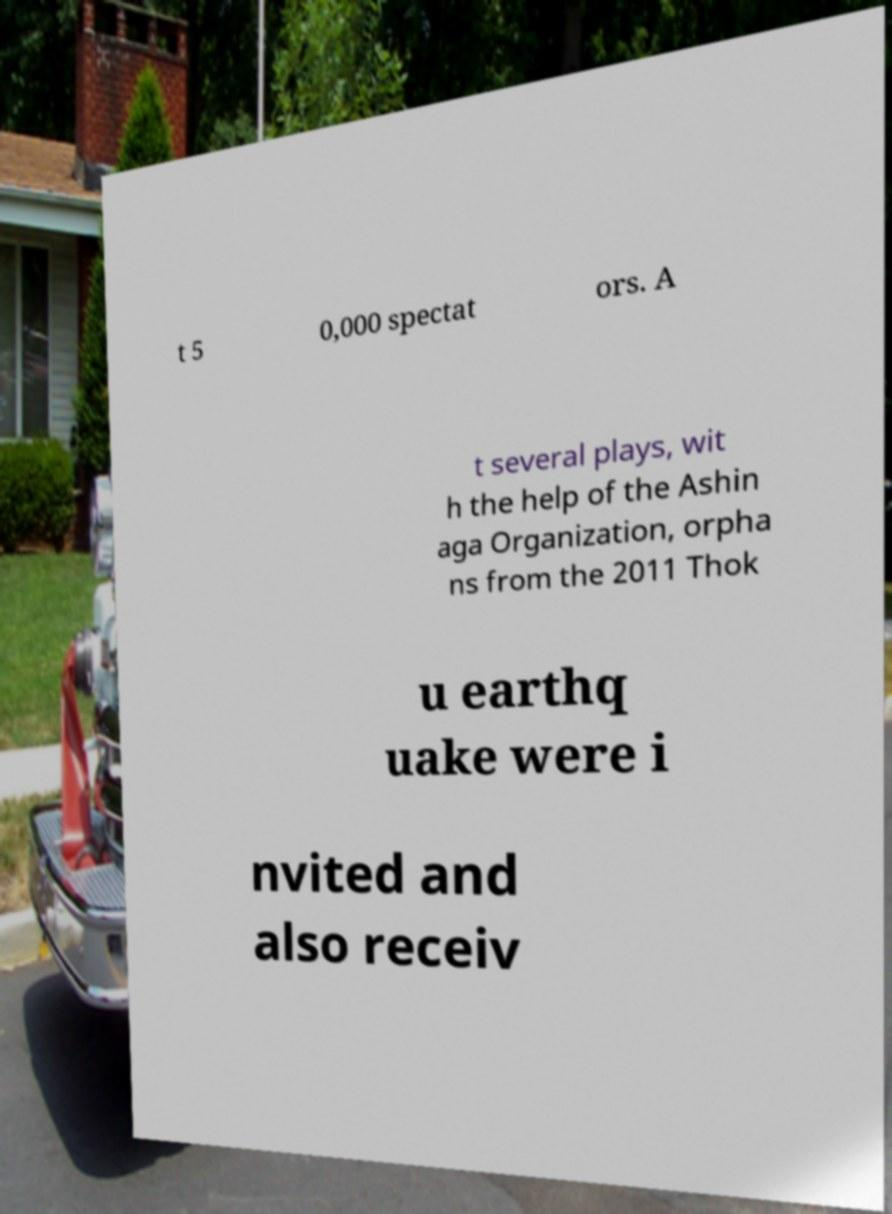Could you extract and type out the text from this image? t 5 0,000 spectat ors. A t several plays, wit h the help of the Ashin aga Organization, orpha ns from the 2011 Thok u earthq uake were i nvited and also receiv 